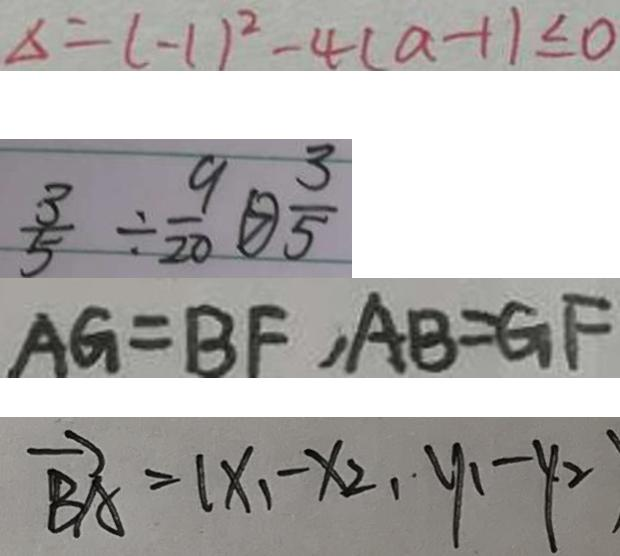Convert formula to latex. <formula><loc_0><loc_0><loc_500><loc_500>\Delta = ( - 1 ) ^ { 2 } - 4 ( a - 1 ) \leq 0 
 \frac { 3 } { 5 } \div \frac { 9 } { 2 0 } \textcircled { > } \frac { 3 } { 5 } 
 A G = B F , A B = G F 
 \overrightarrow { B A } = ( x _ { 1 } - x _ { 2 } , y _ { 1 } - y _ { 2 } )</formula> 